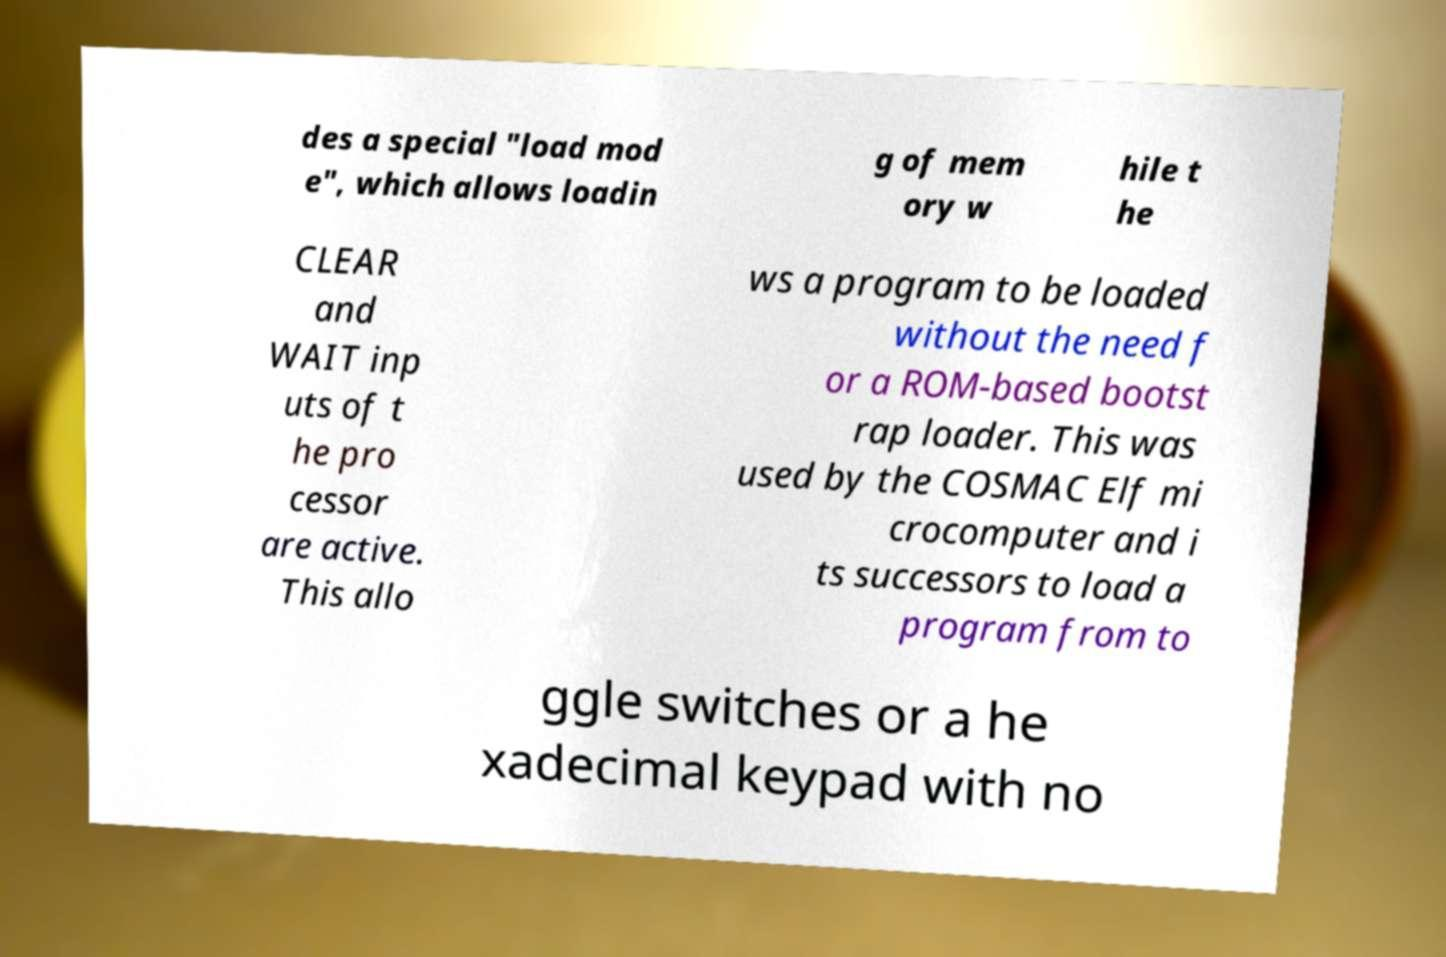Please identify and transcribe the text found in this image. des a special "load mod e", which allows loadin g of mem ory w hile t he CLEAR and WAIT inp uts of t he pro cessor are active. This allo ws a program to be loaded without the need f or a ROM-based bootst rap loader. This was used by the COSMAC Elf mi crocomputer and i ts successors to load a program from to ggle switches or a he xadecimal keypad with no 